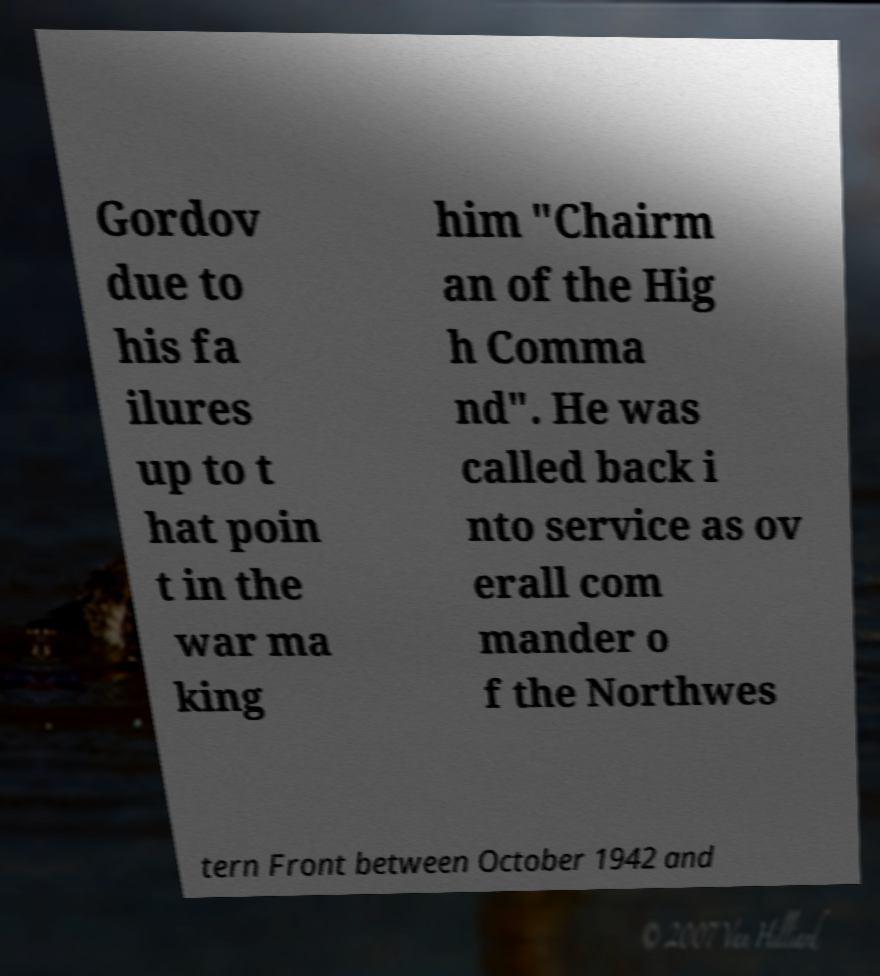For documentation purposes, I need the text within this image transcribed. Could you provide that? Gordov due to his fa ilures up to t hat poin t in the war ma king him "Chairm an of the Hig h Comma nd". He was called back i nto service as ov erall com mander o f the Northwes tern Front between October 1942 and 